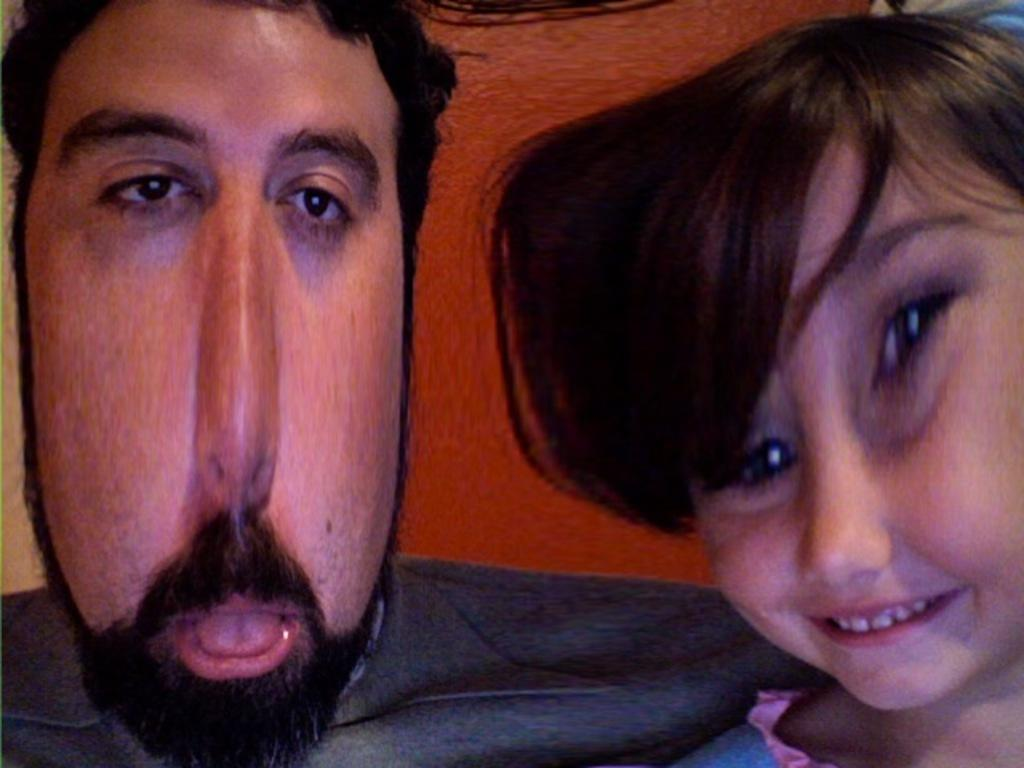Who is present in the image? There is a person in the image. Can you describe the person in the image? There is a girl in the image. What is the girl doing in the image? The girl is smiling. What color is the wall in the background of the image? There is an orange color wall in the background of the image. What type of joke can be heard in the image? There is no indication of a joke being told or heard in the image. 